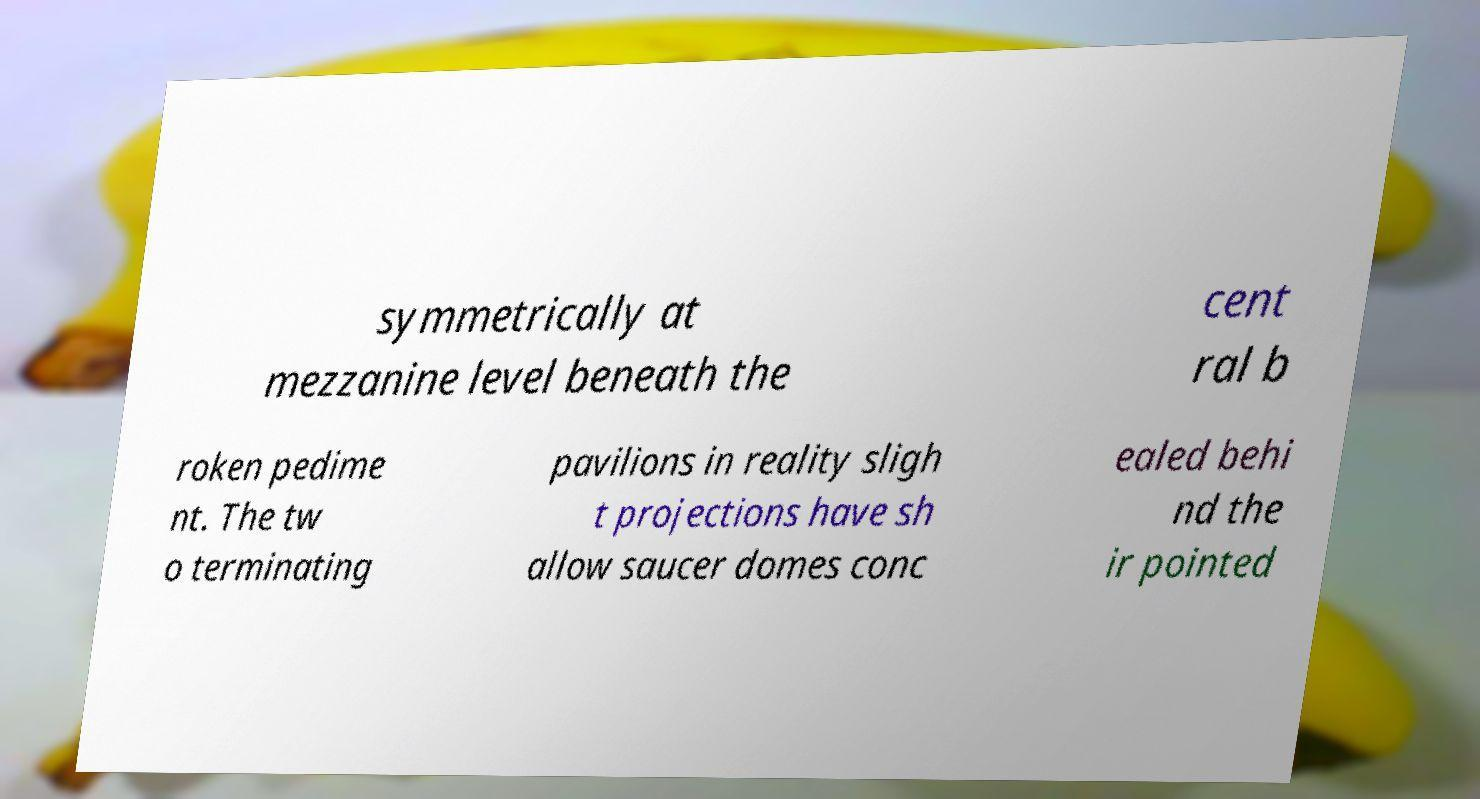I need the written content from this picture converted into text. Can you do that? symmetrically at mezzanine level beneath the cent ral b roken pedime nt. The tw o terminating pavilions in reality sligh t projections have sh allow saucer domes conc ealed behi nd the ir pointed 